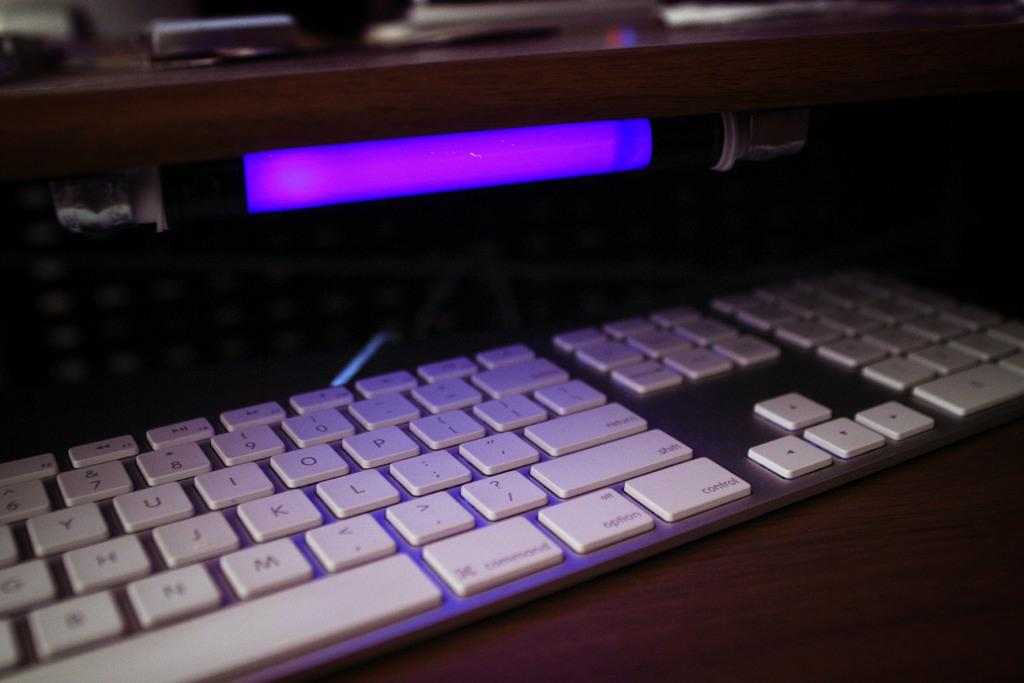What type of device is present in the image? There is a keyboard in the image. What color is the keyboard? The keyboard is white in color. What other object can be seen in the image? There is a light in the image. What is the color of the light? The light is in brinjal color. How many pies are being served on the keyboard in the image? There are no pies present in the image, as it features a keyboard and a light. What type of loss is being experienced by the person in the image? There is no person present in the image, and therefore no loss can be observed. 